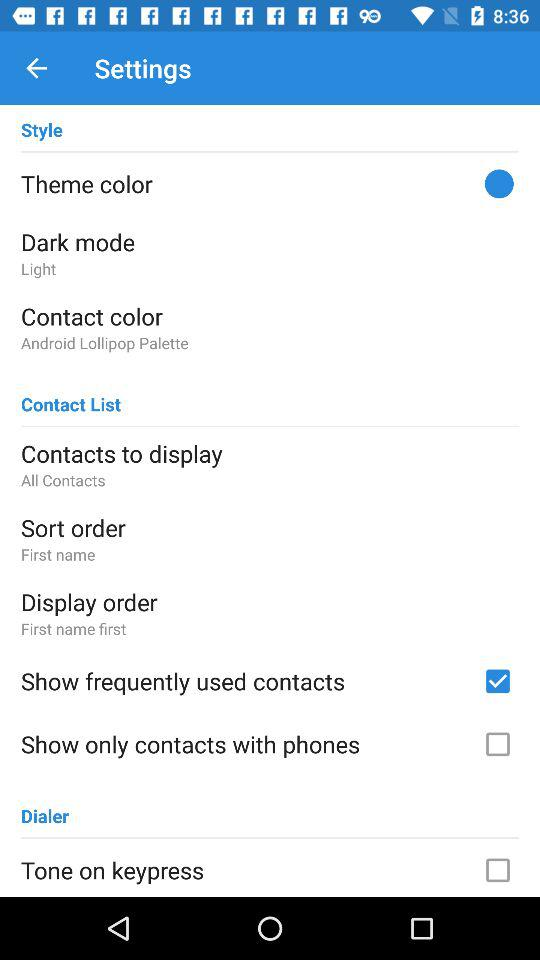What is the dark mode? The dark mode is "Light". 